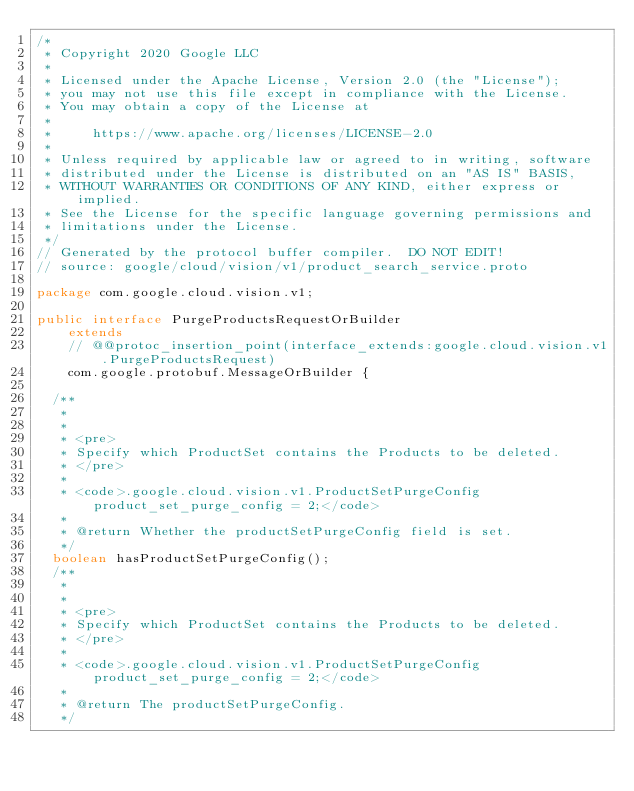<code> <loc_0><loc_0><loc_500><loc_500><_Java_>/*
 * Copyright 2020 Google LLC
 *
 * Licensed under the Apache License, Version 2.0 (the "License");
 * you may not use this file except in compliance with the License.
 * You may obtain a copy of the License at
 *
 *     https://www.apache.org/licenses/LICENSE-2.0
 *
 * Unless required by applicable law or agreed to in writing, software
 * distributed under the License is distributed on an "AS IS" BASIS,
 * WITHOUT WARRANTIES OR CONDITIONS OF ANY KIND, either express or implied.
 * See the License for the specific language governing permissions and
 * limitations under the License.
 */
// Generated by the protocol buffer compiler.  DO NOT EDIT!
// source: google/cloud/vision/v1/product_search_service.proto

package com.google.cloud.vision.v1;

public interface PurgeProductsRequestOrBuilder
    extends
    // @@protoc_insertion_point(interface_extends:google.cloud.vision.v1.PurgeProductsRequest)
    com.google.protobuf.MessageOrBuilder {

  /**
   *
   *
   * <pre>
   * Specify which ProductSet contains the Products to be deleted.
   * </pre>
   *
   * <code>.google.cloud.vision.v1.ProductSetPurgeConfig product_set_purge_config = 2;</code>
   *
   * @return Whether the productSetPurgeConfig field is set.
   */
  boolean hasProductSetPurgeConfig();
  /**
   *
   *
   * <pre>
   * Specify which ProductSet contains the Products to be deleted.
   * </pre>
   *
   * <code>.google.cloud.vision.v1.ProductSetPurgeConfig product_set_purge_config = 2;</code>
   *
   * @return The productSetPurgeConfig.
   */</code> 